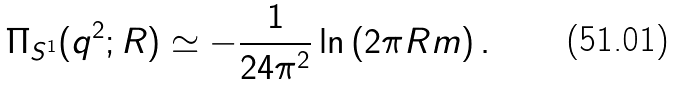<formula> <loc_0><loc_0><loc_500><loc_500>\Pi _ { S ^ { 1 } } ( q ^ { 2 } ; R ) \simeq - { \frac { 1 } { 2 4 \pi ^ { 2 } } } \ln \left ( 2 \pi R m \right ) .</formula> 